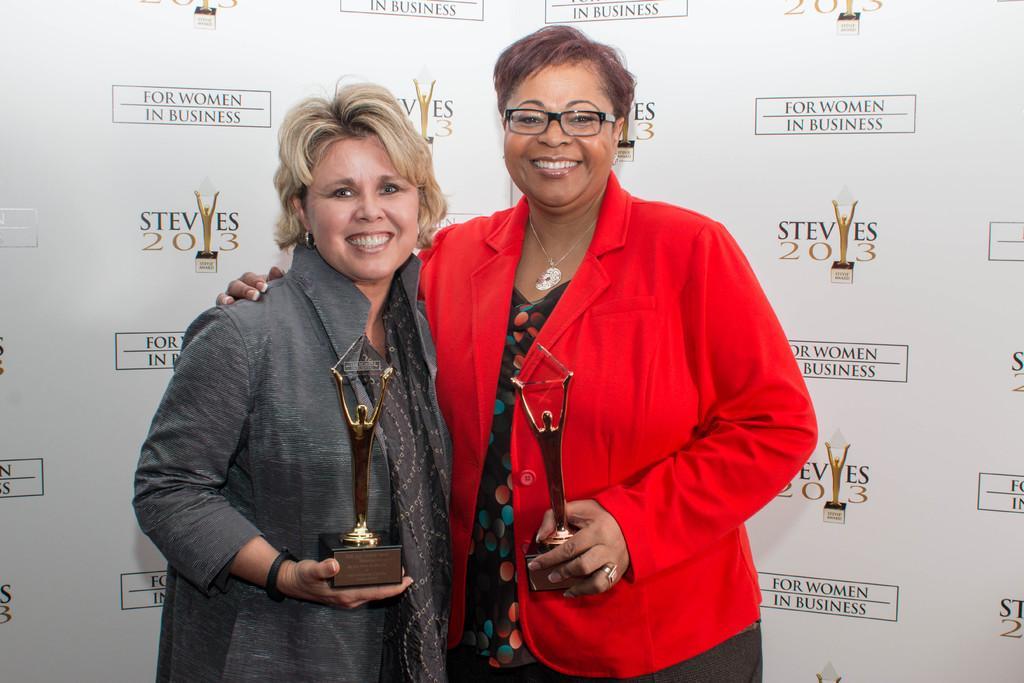In one or two sentences, can you explain what this image depicts? As we can see in the image there is a banner and two women holding statues. The woman over here is wearing a black color jacket and the woman next to her is wearing red color jacket. 